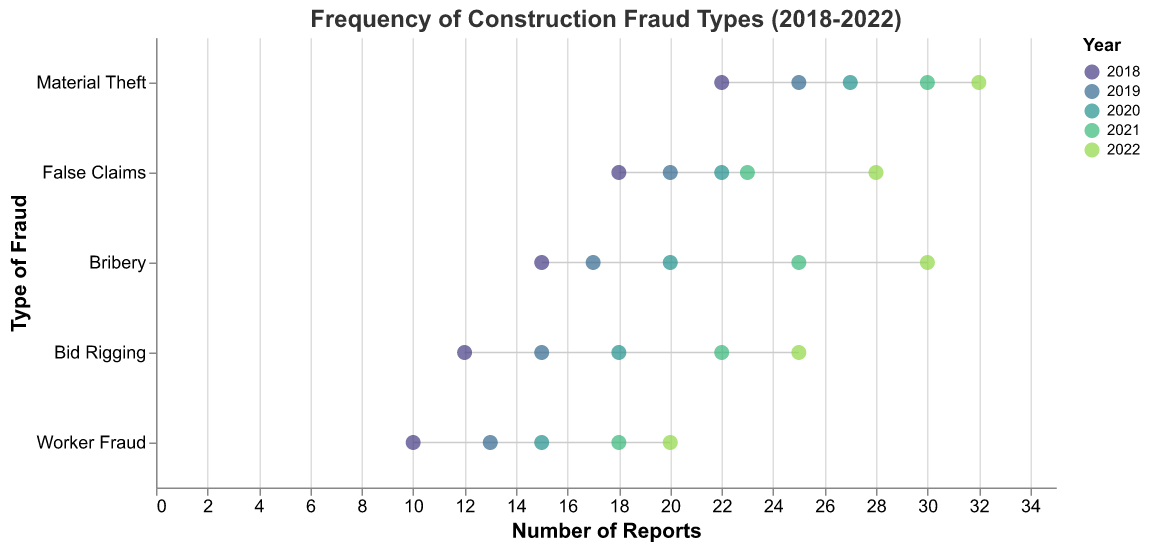What's the highest reported type of fraud in 2022? Look for the type of fraud with the highest number of reports in 2022. Material Theft has 32 reports.
Answer: Material Theft Which year had the maximum bribery reports? Check the number of bribery reports each year and find the year with the highest value. 2022 had 30 bribery reports.
Answer: 2022 What is the range of false claims reports over the years? Identify the minimum and maximum number of reports for false claims from 2018 to 2022. The range is from 18 to 28.
Answer: 18 to 28 How did the number of bid rigging reports change from 2018 to 2022? Track the number of reports for bid rigging from 2018 to 2022. The numbers are 12, 15, 18, 22, and 25 respectively, showing an increasing trend.
Answer: Increased Which type of fraud showed the most significant increase in reports from 2018 to 2022? Calculate the difference in reports for all fraud types between 2018 and 2022. Material Theft increased from 22 to 32, which is the largest change of +10.
Answer: Material Theft What is the average number of worker fraud reports over the five years? Sum all worker fraud reports from 2018 to 2022 (10+13+15+18+20) and divide by five. The sum is 76, so the average is 76/5 = 15.2.
Answer: 15.2 Which type of fraud had the smallest increase in reports from 2018 to 2022? Calculate the difference in reports for all fraud types between 2018 and 2022. Worker Fraud has the smallest increase (from 10 to 20, a change of +10).
Answer: Worker Fraud Between 2020 and 2021, which type of fraud had the highest increase in reports? Compare the number of reports for each type of fraud in 2020 and 2021. Bribery had the highest increase, from 20 to 25, an increase of 5.
Answer: Bribery What is the total number of material theft reports from 2018 to 2022? Sum all material theft reports from 2018 to 2022 (22+25+27+30+32). The total is 136.
Answer: 136 Which type of fraud consistently increased every year from 2018 to 2022? Check the yearly reports for each fraud type and see which type shows a consistent increase. Bid Rigging consistently increased each year.
Answer: Bid Rigging 